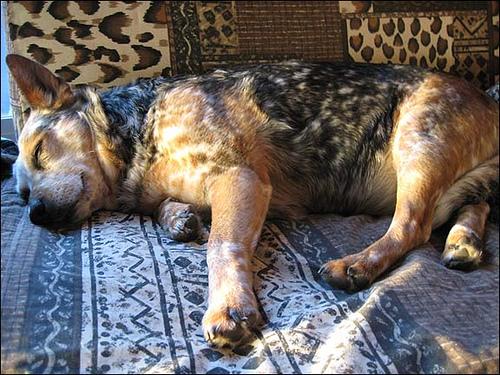Is the dog tired?
Keep it brief. Yes. What is the dog doing?
Keep it brief. Sleeping. What kind of animal is this?
Keep it brief. Dog. 